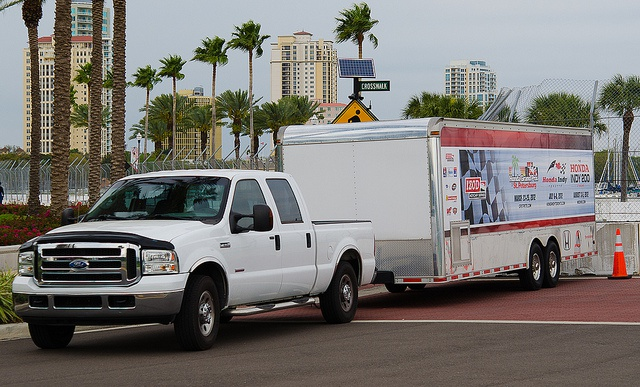Describe the objects in this image and their specific colors. I can see a truck in gray, darkgray, black, and lightgray tones in this image. 